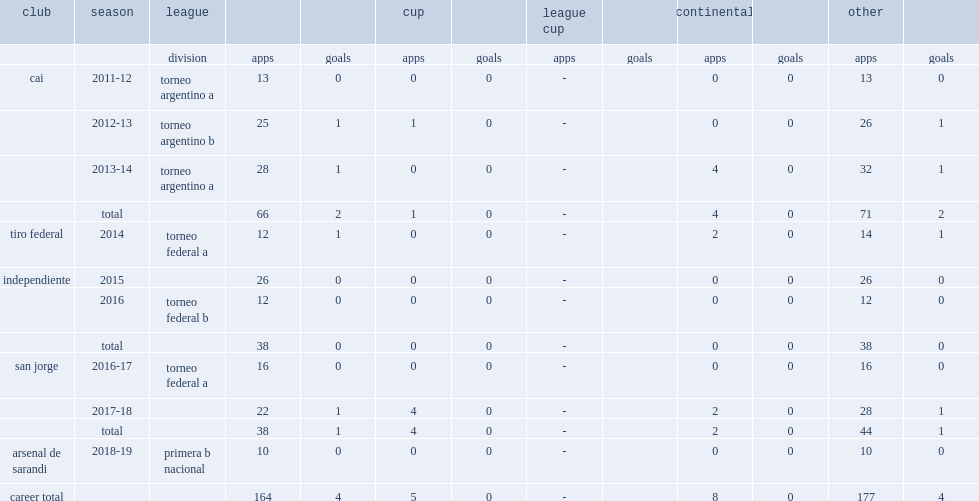Which division did pereyra join in 2018-19 season? Primera b nacional. Help me parse the entirety of this table. {'header': ['club', 'season', 'league', '', '', 'cup', '', 'league cup', '', 'continental', '', 'other', ''], 'rows': [['', '', 'division', 'apps', 'goals', 'apps', 'goals', 'apps', 'goals', 'apps', 'goals', 'apps', 'goals'], ['cai', '2011-12', 'torneo argentino a', '13', '0', '0', '0', '-', '', '0', '0', '13', '0'], ['', '2012-13', 'torneo argentino b', '25', '1', '1', '0', '-', '', '0', '0', '26', '1'], ['', '2013-14', 'torneo argentino a', '28', '1', '0', '0', '-', '', '4', '0', '32', '1'], ['', 'total', '', '66', '2', '1', '0', '-', '', '4', '0', '71', '2'], ['tiro federal', '2014', 'torneo federal a', '12', '1', '0', '0', '-', '', '2', '0', '14', '1'], ['independiente', '2015', '', '26', '0', '0', '0', '-', '', '0', '0', '26', '0'], ['', '2016', 'torneo federal b', '12', '0', '0', '0', '-', '', '0', '0', '12', '0'], ['', 'total', '', '38', '0', '0', '0', '-', '', '0', '0', '38', '0'], ['san jorge', '2016-17', 'torneo federal a', '16', '0', '0', '0', '-', '', '0', '0', '16', '0'], ['', '2017-18', '', '22', '1', '4', '0', '-', '', '2', '0', '28', '1'], ['', 'total', '', '38', '1', '4', '0', '-', '', '2', '0', '44', '1'], ['arsenal de sarandi', '2018-19', 'primera b nacional', '10', '0', '0', '0', '-', '', '0', '0', '10', '0'], ['career total', '', '', '164', '4', '5', '0', '-', '', '8', '0', '177', '4']]} 